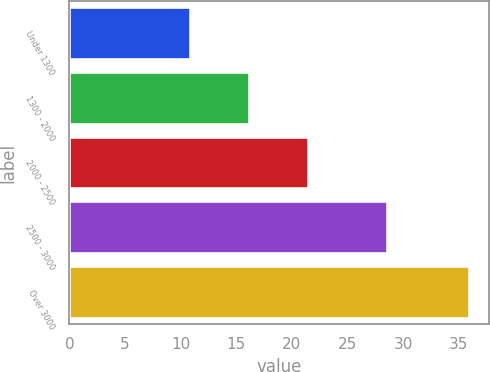Convert chart. <chart><loc_0><loc_0><loc_500><loc_500><bar_chart><fcel>Under 1300<fcel>1300 - 2000<fcel>2000 - 2500<fcel>2500 - 3000<fcel>Over 3000<nl><fcel>10.85<fcel>16.16<fcel>21.46<fcel>28.54<fcel>35.94<nl></chart> 